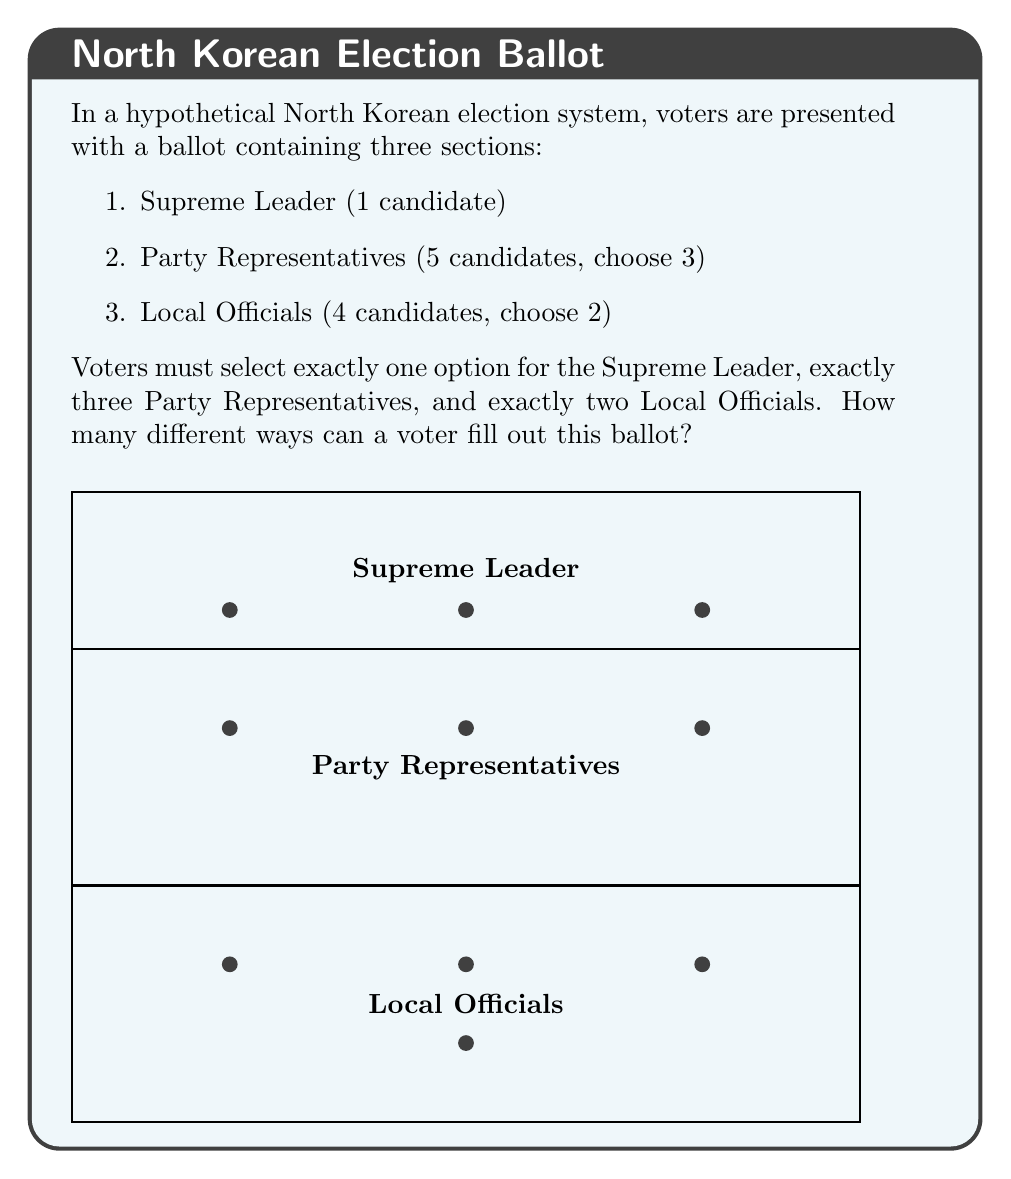What is the answer to this math problem? Let's break this down step-by-step using the multiplication principle of counting:

1. Supreme Leader section:
   There is only 1 candidate, so there is only 1 way to fill this section.

2. Party Representatives section:
   We need to choose 3 out of 5 candidates. This is a combination problem.
   The number of ways to do this is:
   $$\binom{5}{3} = \frac{5!}{3!(5-3)!} = \frac{5!}{3!2!} = 10$$

3. Local Officials section:
   We need to choose 2 out of 4 candidates. Again, this is a combination:
   $$\binom{4}{2} = \frac{4!}{2!(4-2)!} = \frac{4!}{2!2!} = 6$$

4. To get the total number of ways to fill out the ballot, we multiply these together:
   $$1 \times 10 \times 6 = 60$$

Therefore, there are 60 different ways a voter can fill out this ballot.
Answer: 60 